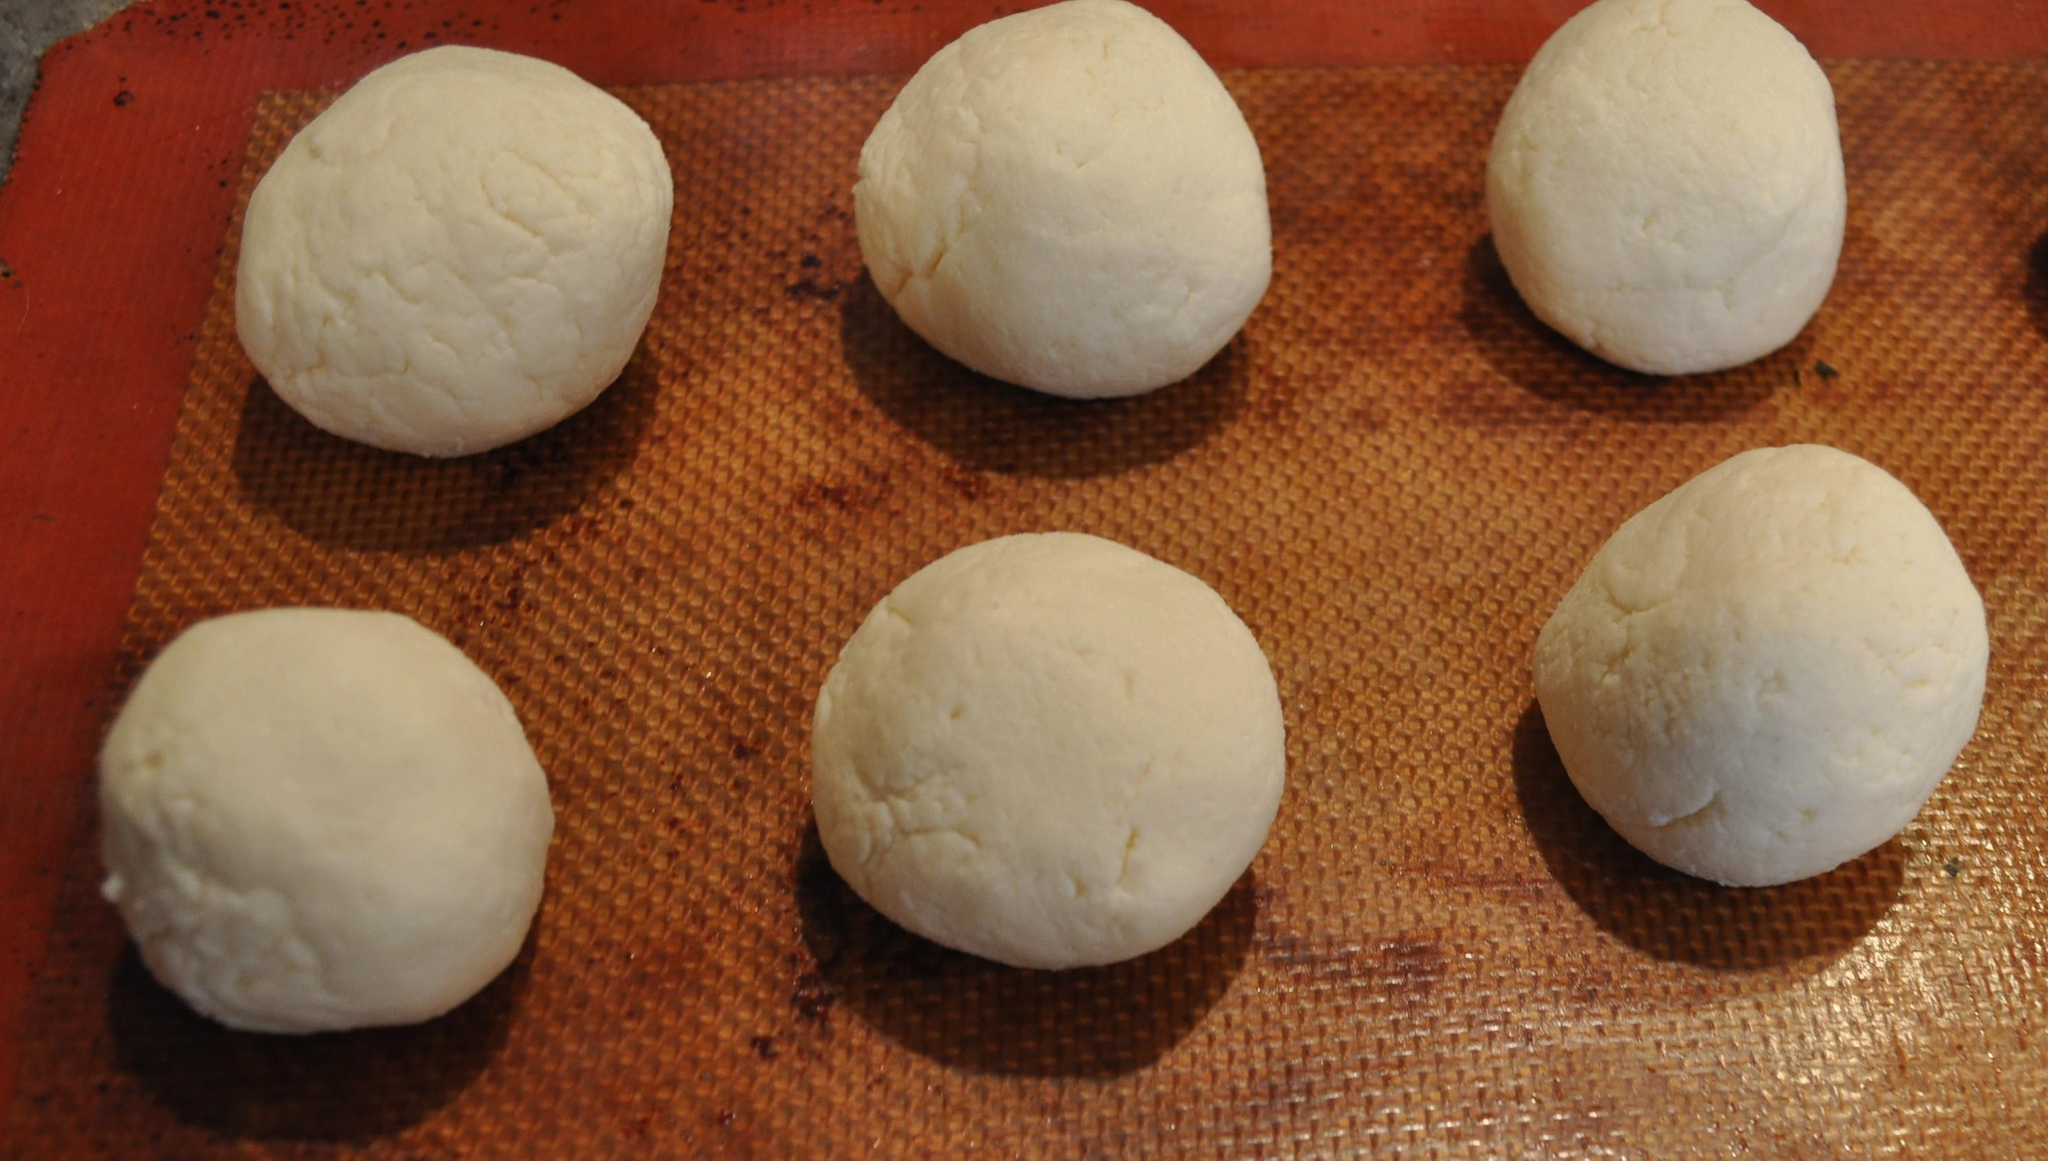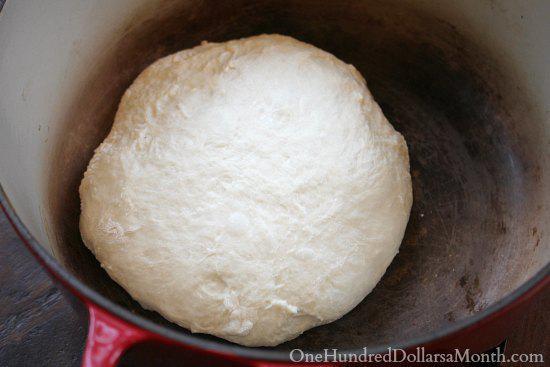The first image is the image on the left, the second image is the image on the right. Assess this claim about the two images: "Each image contains one rounded ball of raw dough.". Correct or not? Answer yes or no. No. The first image is the image on the left, the second image is the image on the right. Evaluate the accuracy of this statement regarding the images: "The left and right image contains the same number of balls of dough.". Is it true? Answer yes or no. No. 